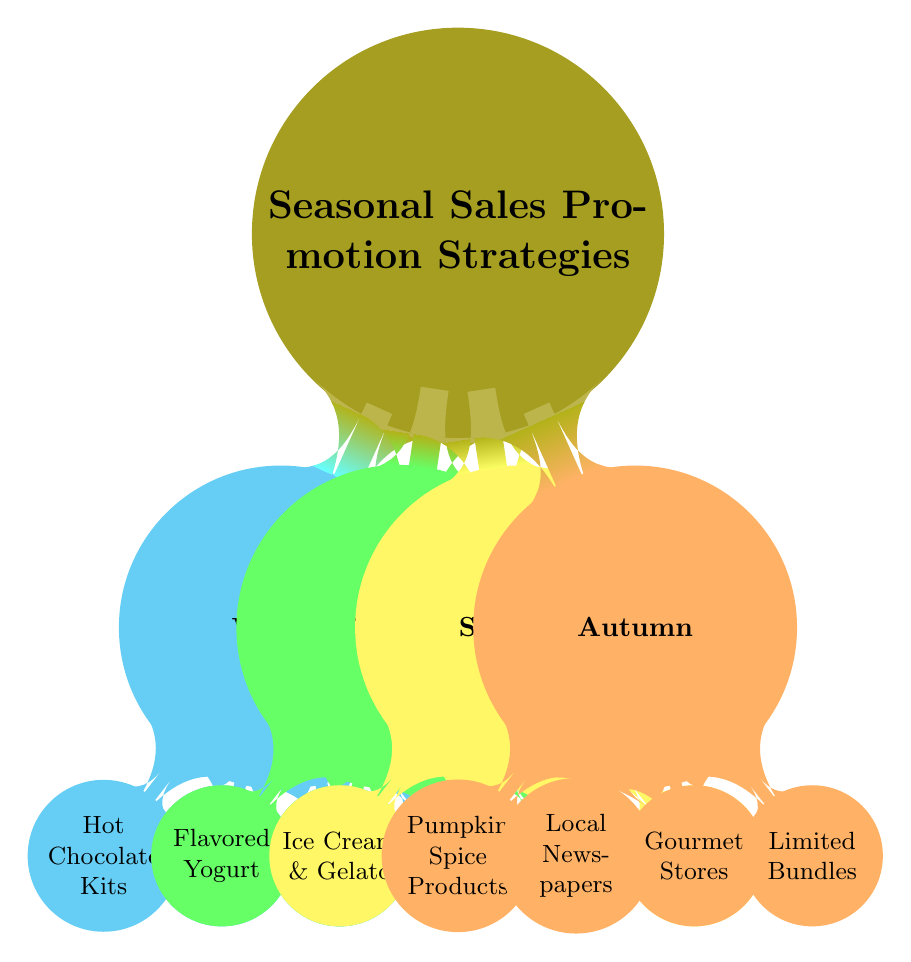What is the product focus for Winter? The diagram shows that the product focus for Winter is Hot Chocolate Kits. This can be found directly under the Winter node.
Answer: Hot Chocolate Kits How many marketing channels are listed for Spring? In the Spring section of the diagram, there is one marketing channel listed, which is Farmers Markets, along with Local Food Festivals. Counting these gives us two marketing channels.
Answer: 2 What special offer appears in the Autumn section? The Autumn section of the diagram specifies a special offer: Limited Edition Bundles. This can be found directly in the Autumn node.
Answer: Limited Edition Bundles Which season features Ice Cream and Gelato as the product focus? The diagram indicates that Summer features Ice Cream and Gelato as the product focus. This information is located under the Summer node.
Answer: Summer What are the marketing channels for the Summer season? For the Summer season, the diagram lists two marketing channels: Social Media and Local Events. This information can be found in the Summer section of the mind map.
Answer: Social Media and Local Events Which partnerships are associated with the Spring promotions? Under the Spring section, the diagram shows that the partnership associated with Spring promotions is Health and Wellness Shops. This detail is located directly under the Spring node.
Answer: Health and Wellness Shops How many special offers are there in total across all seasons? The diagram lists one special offer for each of the four seasons (Winter, Spring, Summer, Autumn), resulting in a total of four special offers. This is found by counting the respective offers for each season.
Answer: 4 Which season has Local Cafes as a partnership? The diagram shows that Local Cafes are mentioned as a partnership under the Winter season. This can be found directly in the Winter section of the mind map.
Answer: Winter 